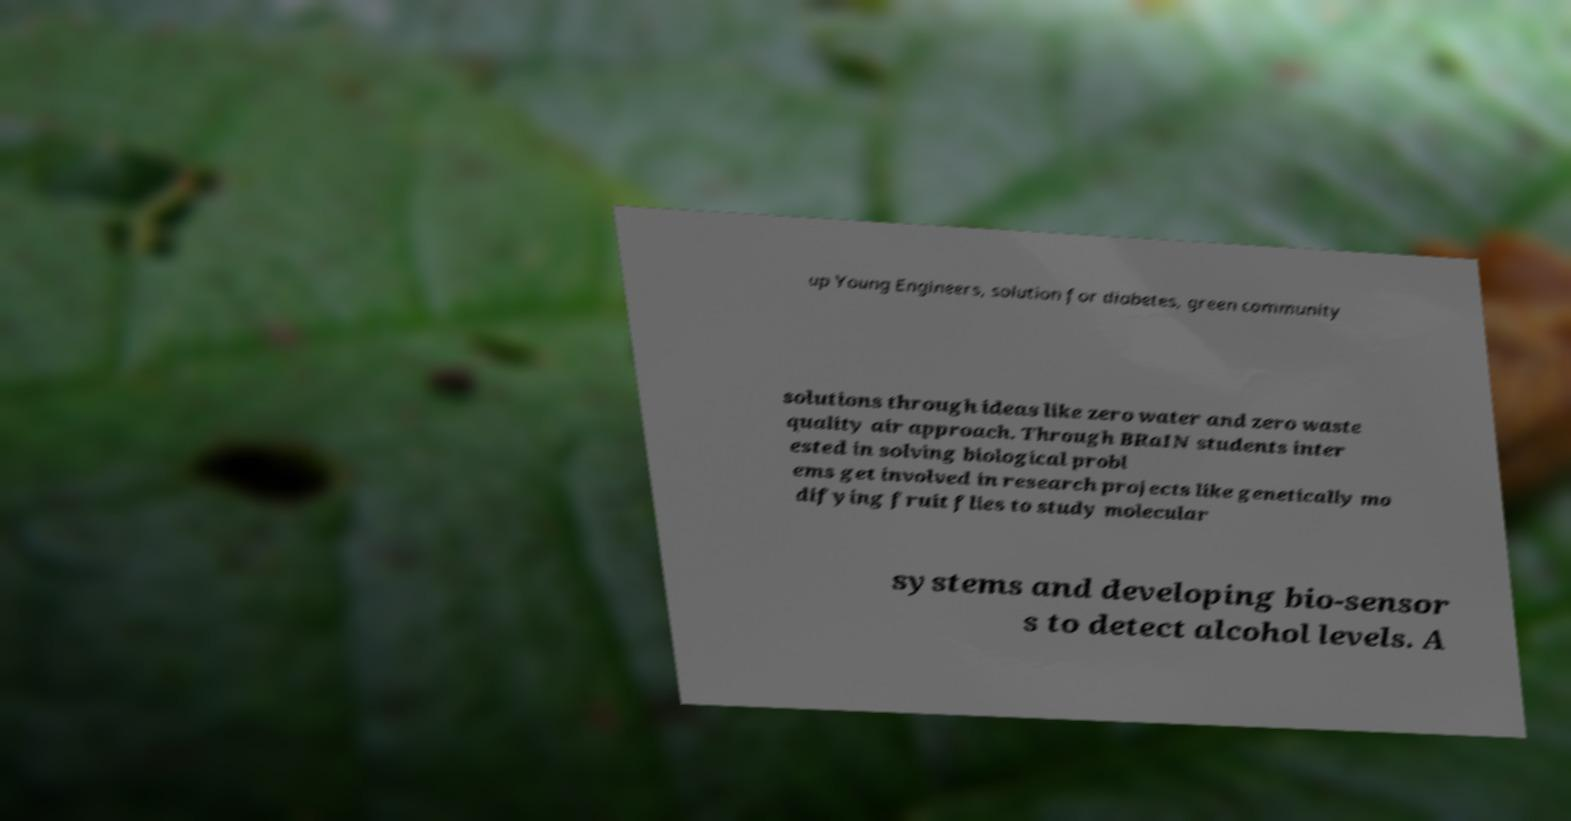Could you extract and type out the text from this image? up Young Engineers, solution for diabetes, green community solutions through ideas like zero water and zero waste quality air approach. Through BRaIN students inter ested in solving biological probl ems get involved in research projects like genetically mo difying fruit flies to study molecular systems and developing bio-sensor s to detect alcohol levels. A 